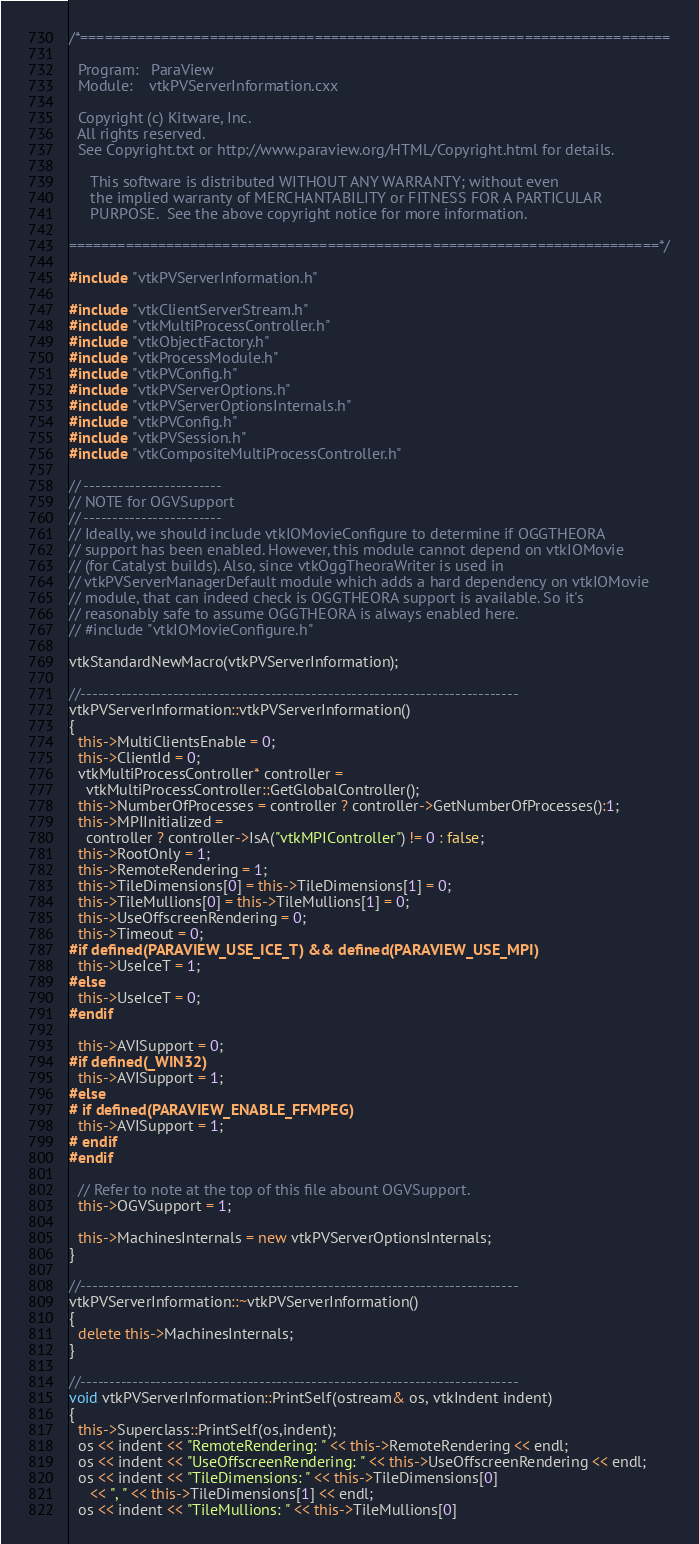Convert code to text. <code><loc_0><loc_0><loc_500><loc_500><_C++_>/*=========================================================================

  Program:   ParaView
  Module:    vtkPVServerInformation.cxx

  Copyright (c) Kitware, Inc.
  All rights reserved.
  See Copyright.txt or http://www.paraview.org/HTML/Copyright.html for details.

     This software is distributed WITHOUT ANY WARRANTY; without even
     the implied warranty of MERCHANTABILITY or FITNESS FOR A PARTICULAR
     PURPOSE.  See the above copyright notice for more information.

=========================================================================*/

#include "vtkPVServerInformation.h"

#include "vtkClientServerStream.h"
#include "vtkMultiProcessController.h"
#include "vtkObjectFactory.h"
#include "vtkProcessModule.h"
#include "vtkPVConfig.h"
#include "vtkPVServerOptions.h"
#include "vtkPVServerOptionsInternals.h"
#include "vtkPVConfig.h"
#include "vtkPVSession.h"
#include "vtkCompositeMultiProcessController.h"

// ------------------------
// NOTE for OGVSupport
// ------------------------
// Ideally, we should include vtkIOMovieConfigure to determine if OGGTHEORA
// support has been enabled. However, this module cannot depend on vtkIOMovie
// (for Catalyst builds). Also, since vtkOggTheoraWriter is used in
// vtkPVServerManagerDefault module which adds a hard dependency on vtkIOMovie
// module, that can indeed check is OGGTHEORA support is available. So it's
// reasonably safe to assume OGGTHEORA is always enabled here.
// #include "vtkIOMovieConfigure.h"

vtkStandardNewMacro(vtkPVServerInformation);

//----------------------------------------------------------------------------
vtkPVServerInformation::vtkPVServerInformation()
{
  this->MultiClientsEnable = 0;
  this->ClientId = 0;
  vtkMultiProcessController* controller =
    vtkMultiProcessController::GetGlobalController();
  this->NumberOfProcesses = controller ? controller->GetNumberOfProcesses():1;
  this->MPIInitialized =
    controller ? controller->IsA("vtkMPIController") != 0 : false;
  this->RootOnly = 1;
  this->RemoteRendering = 1;
  this->TileDimensions[0] = this->TileDimensions[1] = 0;
  this->TileMullions[0] = this->TileMullions[1] = 0;
  this->UseOffscreenRendering = 0;
  this->Timeout = 0;
#if defined(PARAVIEW_USE_ICE_T) && defined(PARAVIEW_USE_MPI)
  this->UseIceT = 1;
#else
  this->UseIceT = 0;
#endif

  this->AVISupport = 0;
#if defined(_WIN32)
  this->AVISupport = 1;
#else
# if defined(PARAVIEW_ENABLE_FFMPEG)
  this->AVISupport = 1;
# endif
#endif

  // Refer to note at the top of this file abount OGVSupport.
  this->OGVSupport = 1;

  this->MachinesInternals = new vtkPVServerOptionsInternals;
}

//----------------------------------------------------------------------------
vtkPVServerInformation::~vtkPVServerInformation()
{
  delete this->MachinesInternals;
}

//----------------------------------------------------------------------------
void vtkPVServerInformation::PrintSelf(ostream& os, vtkIndent indent)
{
  this->Superclass::PrintSelf(os,indent);
  os << indent << "RemoteRendering: " << this->RemoteRendering << endl;
  os << indent << "UseOffscreenRendering: " << this->UseOffscreenRendering << endl;
  os << indent << "TileDimensions: " << this->TileDimensions[0]
     << ", " << this->TileDimensions[1] << endl;
  os << indent << "TileMullions: " << this->TileMullions[0]</code> 